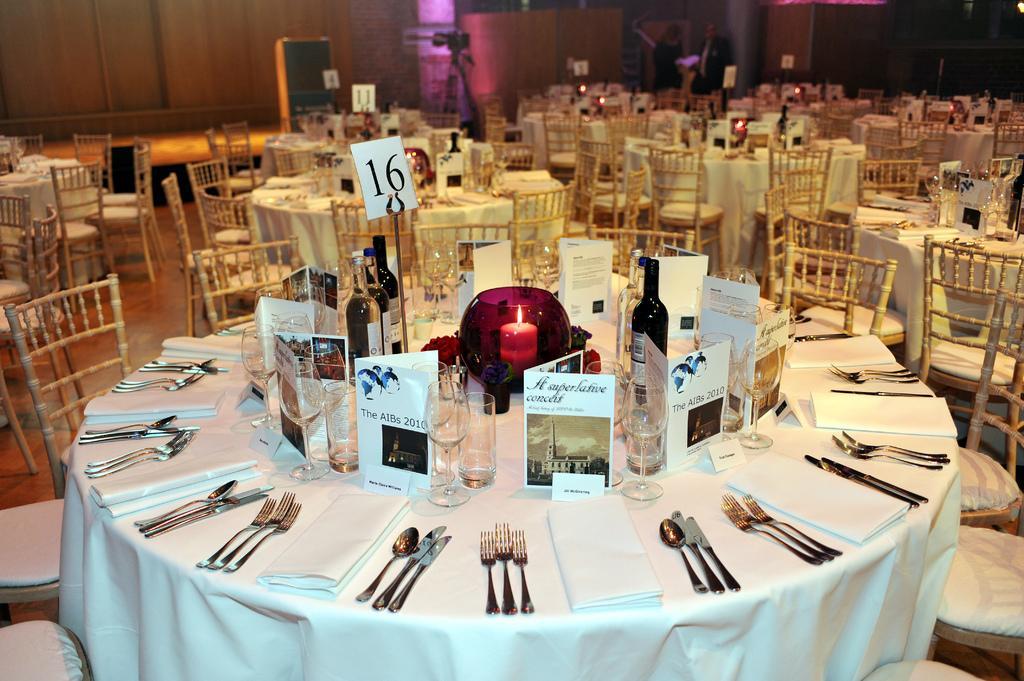Describe this image in one or two sentences. In this image I can see many chairs and tables. On the tables I can see the boards, candle, wine bottles, glasses, forks, knives, spoons and tissues. In the background I can see few more boards and the wall. 